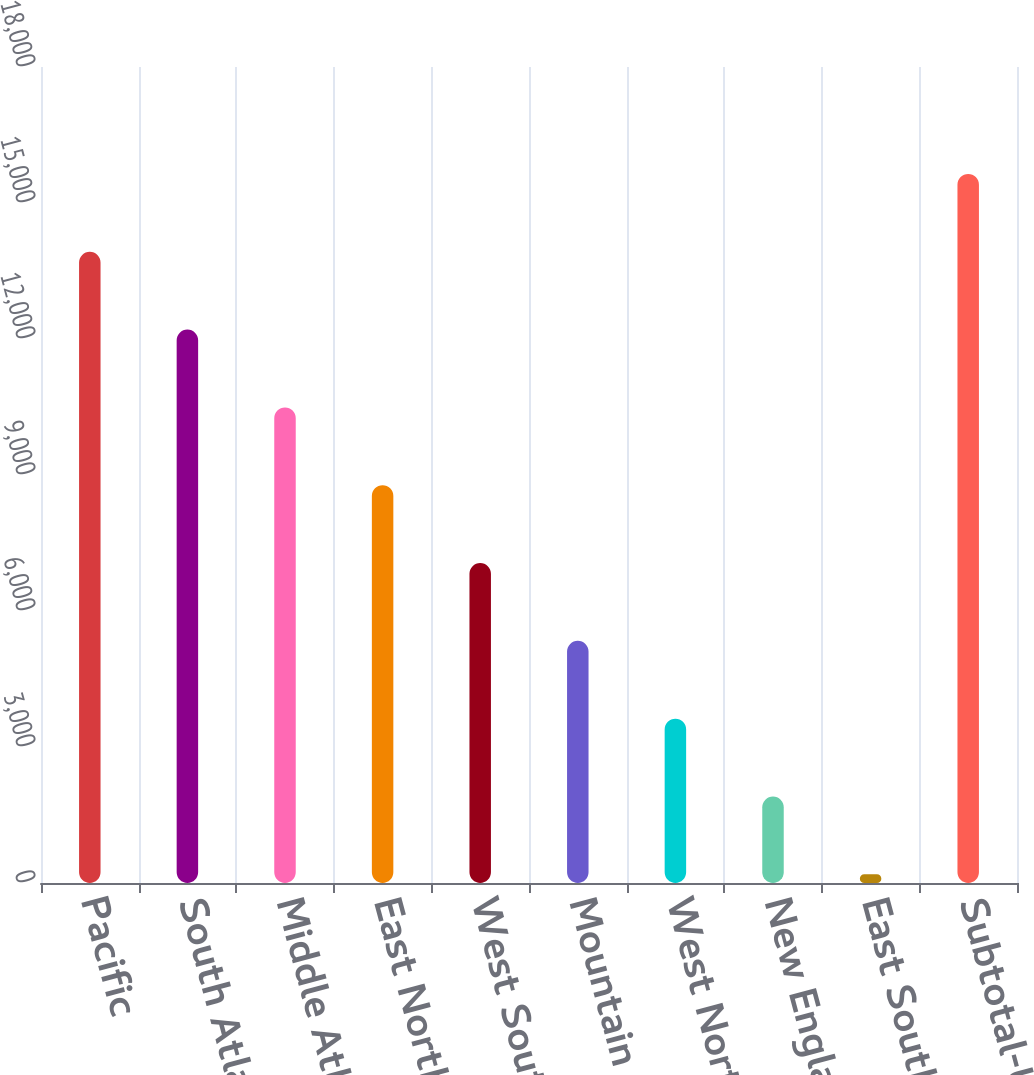<chart> <loc_0><loc_0><loc_500><loc_500><bar_chart><fcel>Pacific<fcel>South Atlantic<fcel>Middle Atlantic<fcel>East North Central<fcel>West South Central<fcel>Mountain<fcel>West North Central<fcel>New England<fcel>East South Central<fcel>Subtotal-US<nl><fcel>13924<fcel>12207.5<fcel>10491<fcel>8774.5<fcel>7058<fcel>5341.5<fcel>3625<fcel>1908.5<fcel>192<fcel>15640.5<nl></chart> 